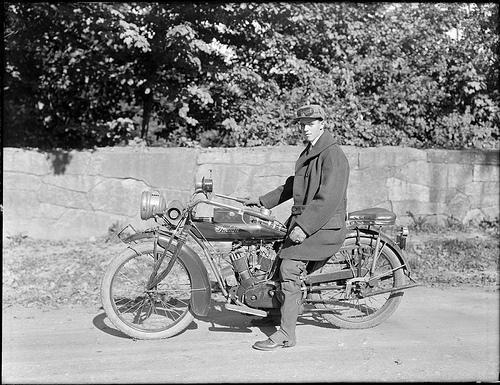How many men are shown?
Give a very brief answer. 1. How many bikes are shown?
Give a very brief answer. 1. How many bikes?
Give a very brief answer. 1. How many wheels are on the vehicle?
Give a very brief answer. 2. How many horses are shown?
Give a very brief answer. 0. 